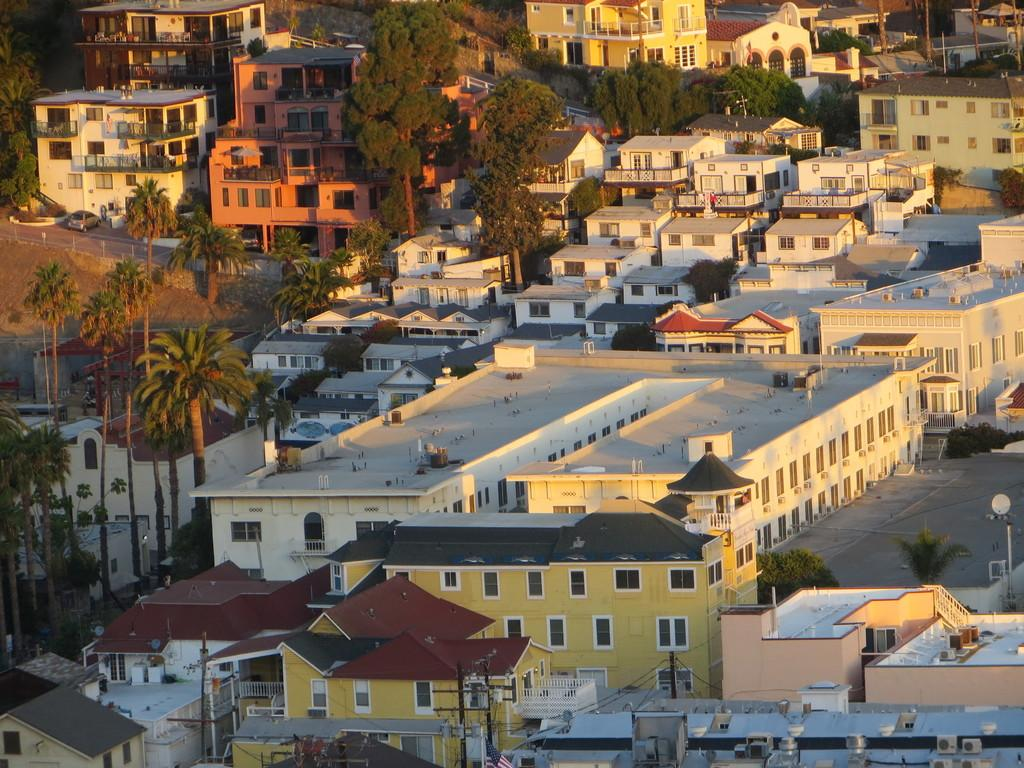What type of structures can be seen in the image? There are buildings in the image. What other elements can be found in the image besides buildings? There are plants, poles, trees, and a car on the road in the image. Can you describe the natural elements present in the image? There are plants and trees in the image. What is the man-made object visible on the road in the image? There is a car on the road in the image. What type of plot is the pig running on in the image? There is no pig present in the image, so it is not possible to answer that question. What sound does the alarm make in the image? There is no alarm present in the image, so it is not possible to answer that question. 